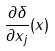Convert formula to latex. <formula><loc_0><loc_0><loc_500><loc_500>\frac { \partial \delta } { \partial x _ { j } } ( x )</formula> 